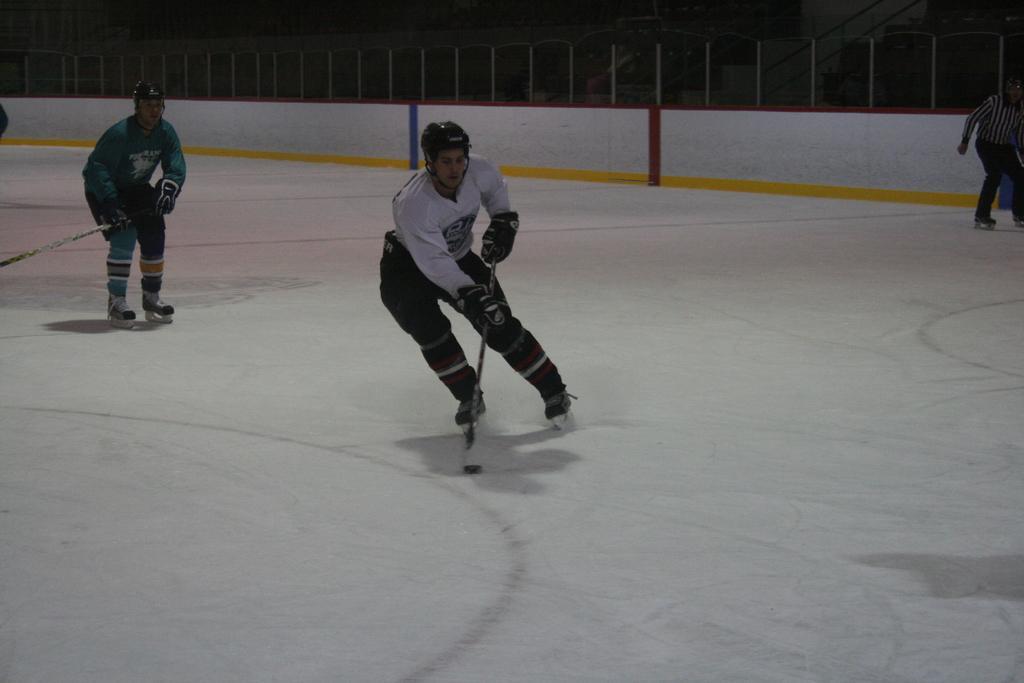In one or two sentences, can you explain what this image depicts? In this picture there is a man who is wearing helmet, white jacket, trouser, gloves and shoe. He is also holding the hockey stick. At the bottom i can see the snow. On the left there is another man who is wearing green jacket, helmet, gloves, trouser and shoe. In the background i can see the fencing and the wall. On the right there is an umpire who is standing near to the blue object. At the top there is a darkness. 